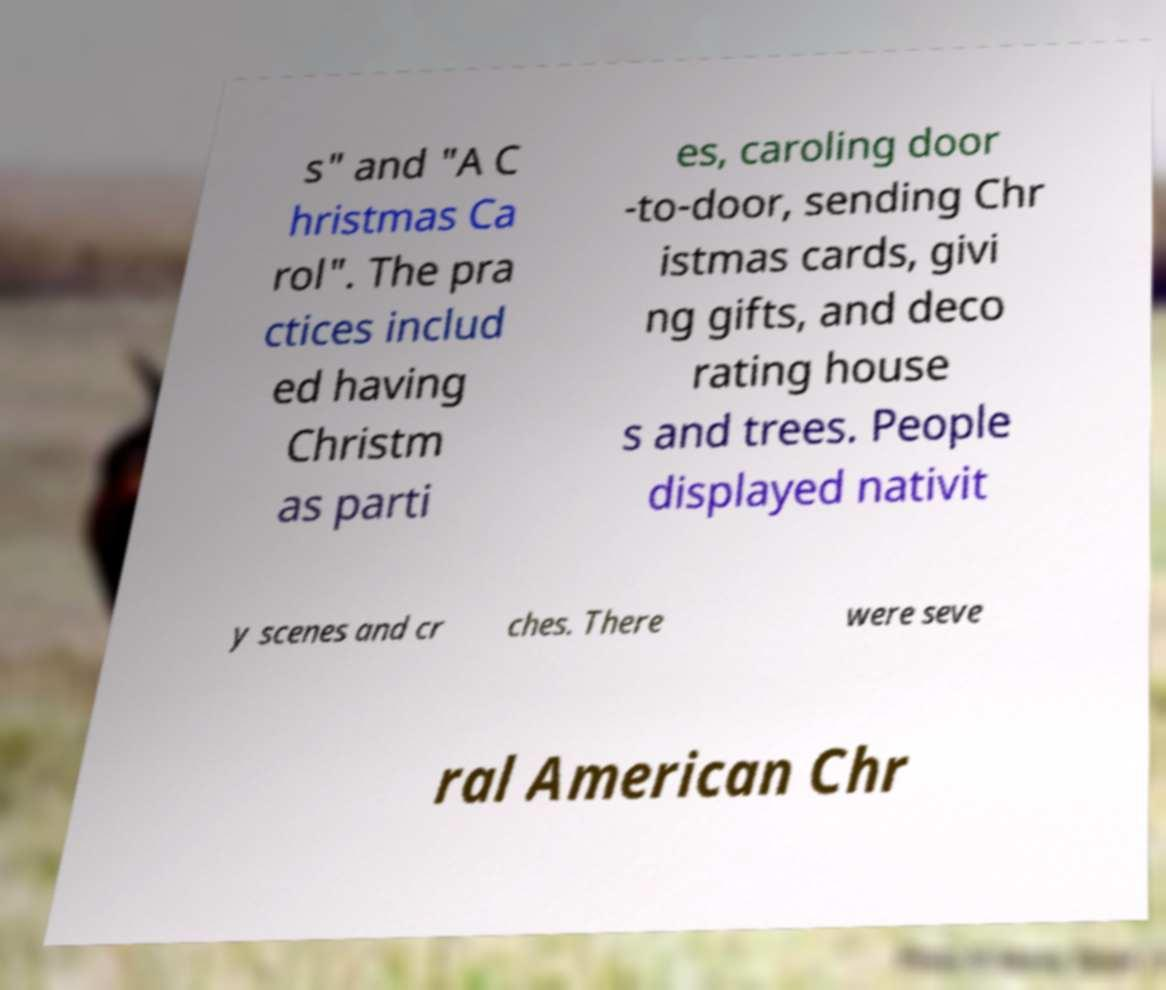Can you read and provide the text displayed in the image?This photo seems to have some interesting text. Can you extract and type it out for me? s" and "A C hristmas Ca rol". The pra ctices includ ed having Christm as parti es, caroling door -to-door, sending Chr istmas cards, givi ng gifts, and deco rating house s and trees. People displayed nativit y scenes and cr ches. There were seve ral American Chr 